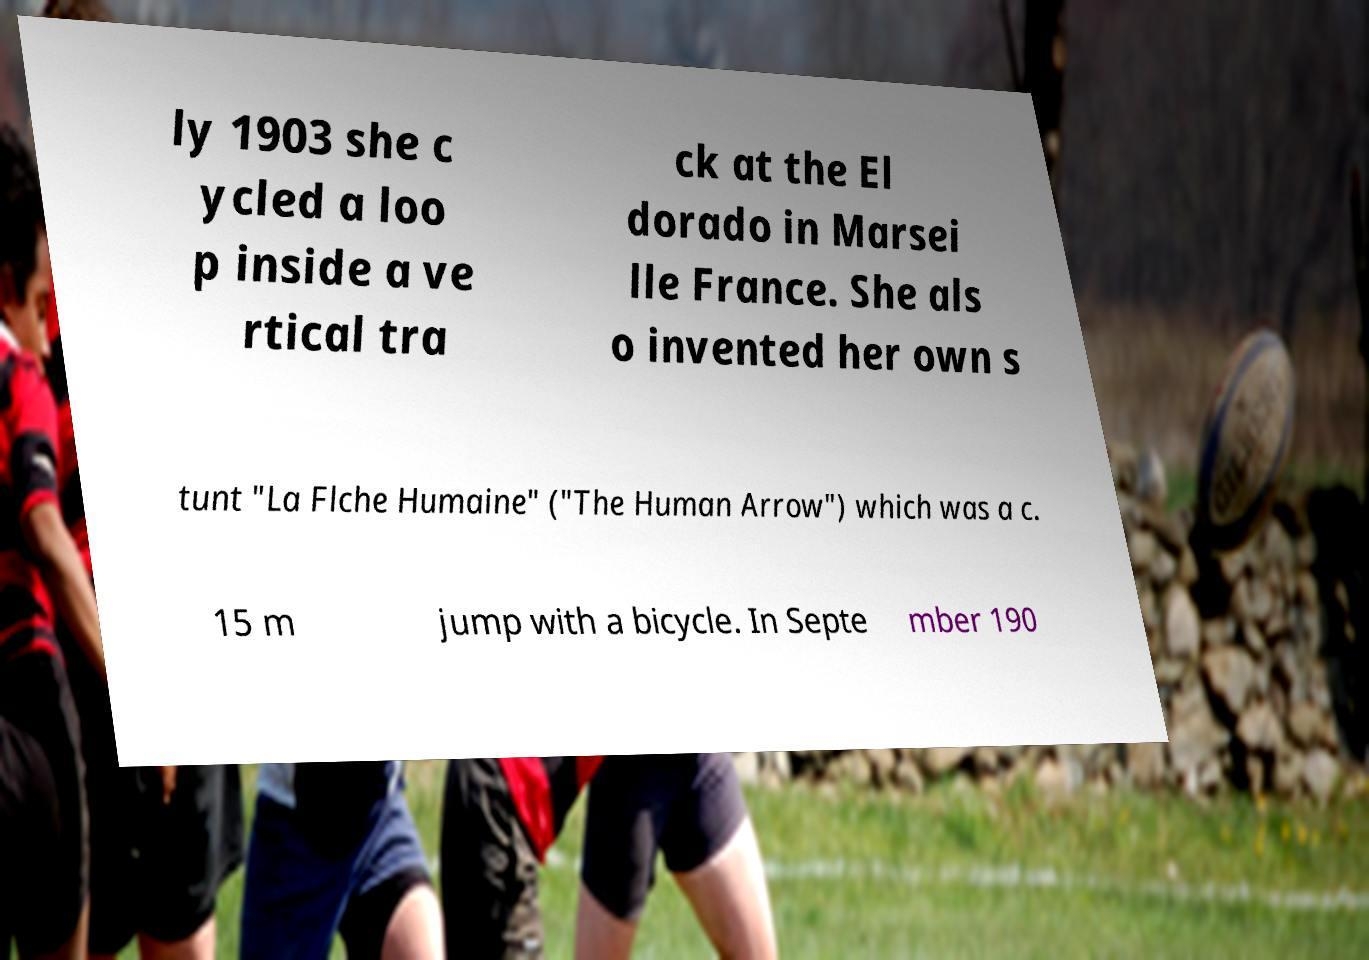Could you assist in decoding the text presented in this image and type it out clearly? ly 1903 she c ycled a loo p inside a ve rtical tra ck at the El dorado in Marsei lle France. She als o invented her own s tunt "La Flche Humaine" ("The Human Arrow") which was a c. 15 m jump with a bicycle. In Septe mber 190 